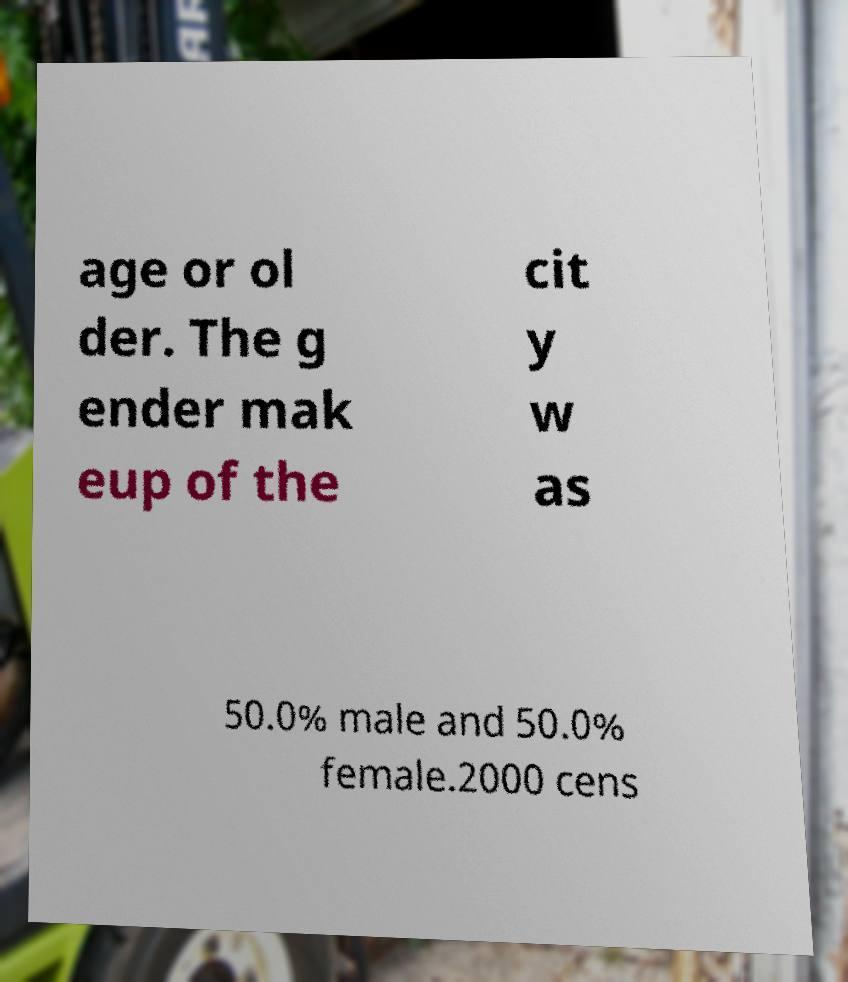What messages or text are displayed in this image? I need them in a readable, typed format. age or ol der. The g ender mak eup of the cit y w as 50.0% male and 50.0% female.2000 cens 